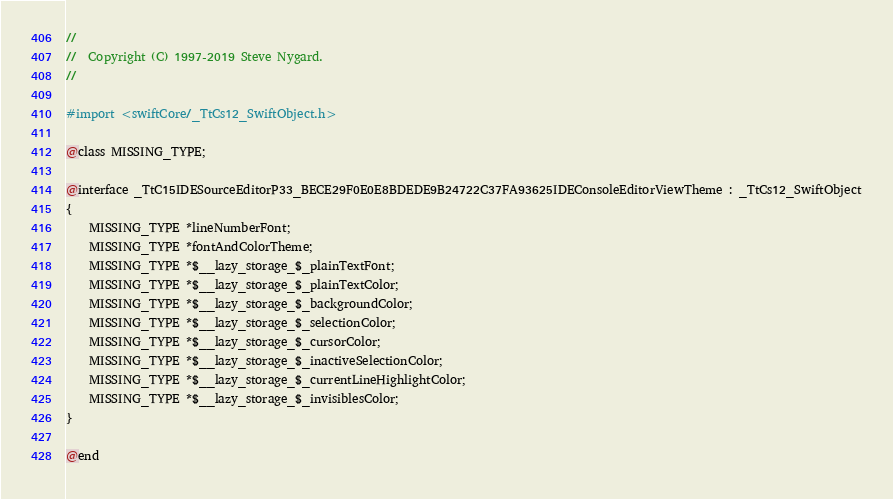<code> <loc_0><loc_0><loc_500><loc_500><_C_>//
//  Copyright (C) 1997-2019 Steve Nygard.
//

#import <swiftCore/_TtCs12_SwiftObject.h>

@class MISSING_TYPE;

@interface _TtC15IDESourceEditorP33_BECE29F0E0E8BDEDE9B24722C37FA93625IDEConsoleEditorViewTheme : _TtCs12_SwiftObject
{
    MISSING_TYPE *lineNumberFont;
    MISSING_TYPE *fontAndColorTheme;
    MISSING_TYPE *$__lazy_storage_$_plainTextFont;
    MISSING_TYPE *$__lazy_storage_$_plainTextColor;
    MISSING_TYPE *$__lazy_storage_$_backgroundColor;
    MISSING_TYPE *$__lazy_storage_$_selectionColor;
    MISSING_TYPE *$__lazy_storage_$_cursorColor;
    MISSING_TYPE *$__lazy_storage_$_inactiveSelectionColor;
    MISSING_TYPE *$__lazy_storage_$_currentLineHighlightColor;
    MISSING_TYPE *$__lazy_storage_$_invisiblesColor;
}

@end

</code> 